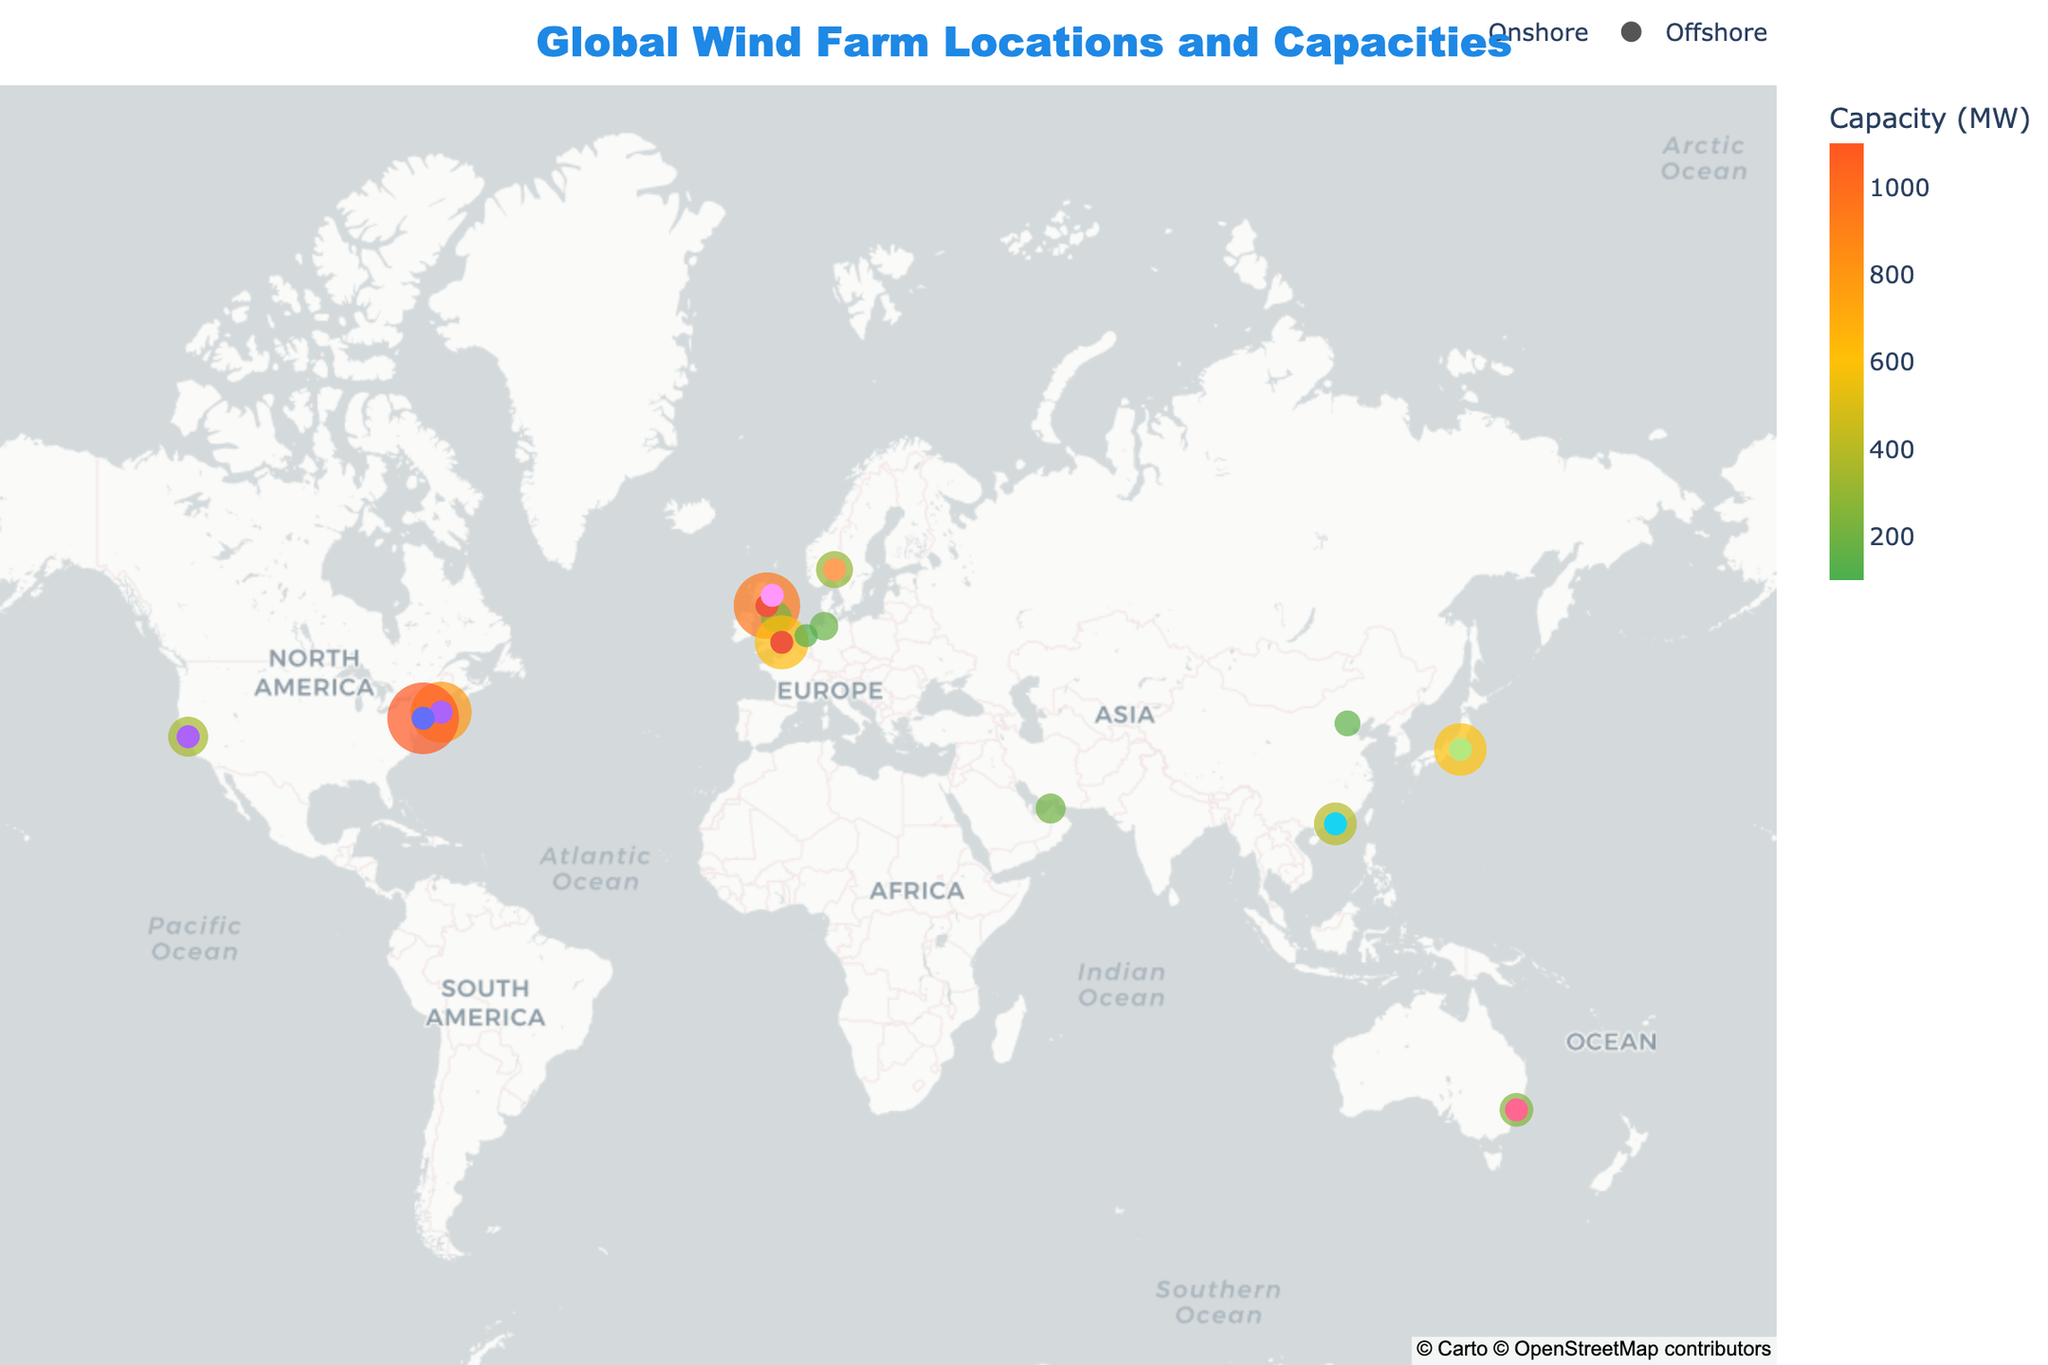What is the title of the figure? The title is usually found at the top of the figure and serves to summarize what the chart is about. The title here is "Global Wind Farm Locations and Capacities."
Answer: Global Wind Farm Locations and Capacities Which wind farm has the highest power generation capacity? To identify this, look for the most eye-catching indicator, which is the size of the point on the map. The larger the size, the higher the capacity. The New York Harbor Wind Project has the largest marker, indicating the highest capacity at 1100 MW.
Answer: New York Harbor Wind Project Are there more offshore or onshore wind farms in the dataset? We need to count and compare the number of markers identified as 'circle' for offshore and 'triangle-up' for onshore respectively. There are more offshore wind farms since the number of circle markers is greater.
Answer: Offshore Which country has the most wind farms listed in the figure? By counting the occurrences of each country's name associated with the plotted wind farms, the United Kingdom appears the most.
Answer: United Kingdom What is the total capacity of all the offshore wind farms combined? Identify all wind farms marked as offshore and sum their capacities. Offshore wind farms and their capacities are: Leith Offshore Wind Farm (950 MW), Vineyard Wind (800 MW), Guishan Offshore Wind Farm (400 MW), Sydney Harbour Wind Farm (250 MW), Tokyo Bay Wind Farm (600 MW), Aberdeen Offshore Wind Farm (100 MW), New York Harbor Wind Project (1100 MW), London Array (630 MW), San Francisco Bay Wind Farm (350 MW), and Oslo Fjord Wind Farm (300 MW). The total is 950 + 800 + 400 + 250 + 600 + 100 + 1100 + 630 + 350 + 300 = 5480 MW.
Answer: 5480 MW Which offshore wind farm has the lowest capacity and what is its value? Look for the smallest marker (circle symbol) amongst the offshore wind farms. Aberdeen Offshore Wind Farm, with a capacity of 100 MW, is the smallest.
Answer: Aberdeen Offshore Wind Farm, 100 MW Are there any countries with both onshore and offshore wind farms represented in the figure? By checking each country mentioned and noting the types of wind farms, the United Kingdom has both offshore (Leith Offshore Wind Farm, Aberdeen Offshore Wind Farm, London Array) and onshore (Teesside Wind Farm) wind farms.
Answer: United Kingdom What is the average capacity of onshore wind farms in the figure? Identify all onshore wind farms and calculate their average capacity: Teesside Wind Farm (210 MW), Bremerhaven Wind Farm (180 MW), Beijing Renewable Energy Park (150 MW), Amsterdam Wind Energy Hub (120 MW), Dubai Clean Energy Park (200 MW). The sum is 210 + 180 + 150 + 120 + 200 = 860 MW. There are 5 onshore farms, so the average is 860 / 5 = 172 MW.
Answer: 172 MW Which location is closest to the equator among the listed wind farms? The equator is at 0 degrees latitude. The wind farm with a latitude closest to 0 is Dubai Clean Energy Park at 25.2048 degrees latitude.
Answer: Dubai Clean Energy Park Which wind farm in Europe has the highest capacity? Identify European wind farms and compare their capacities. European nations included are the United Kingdom, Germany, and Norway. The wind farm with the highest capacity is Leith Offshore Wind Farm in the United Kingdom with 950 MW.
Answer: Leith Offshore Wind Farm 